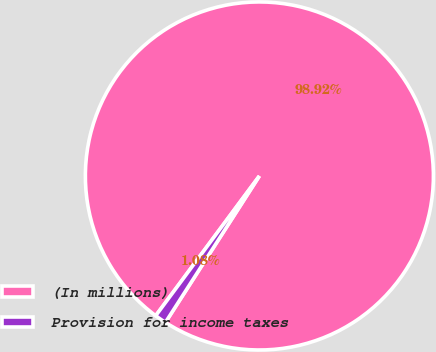<chart> <loc_0><loc_0><loc_500><loc_500><pie_chart><fcel>(In millions)<fcel>Provision for income taxes<nl><fcel>98.92%<fcel>1.08%<nl></chart> 